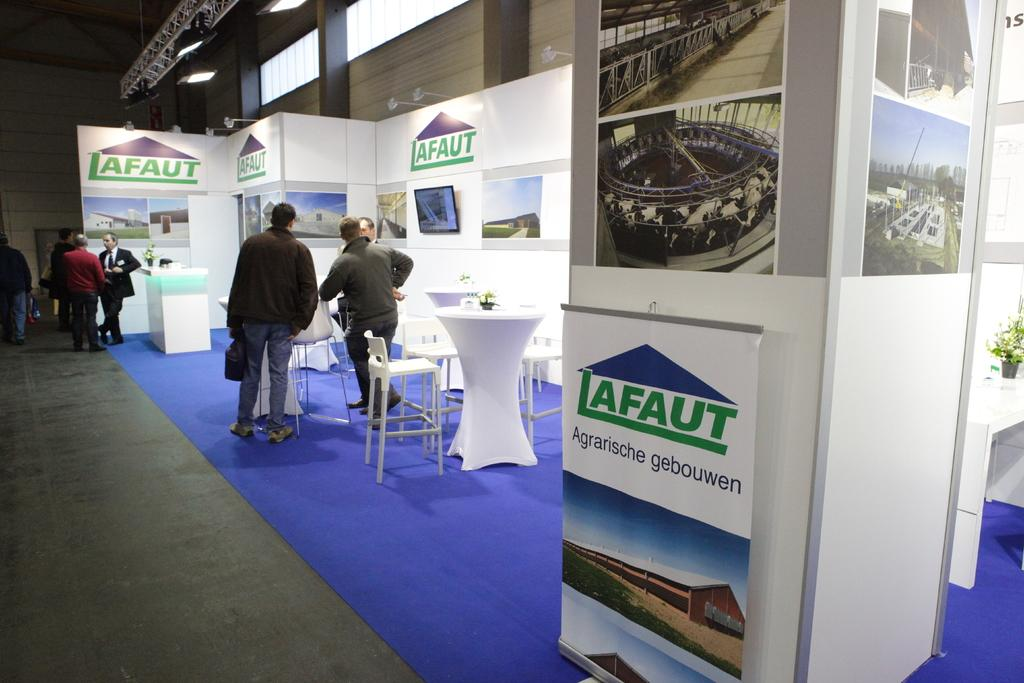<image>
Present a compact description of the photo's key features. A trade show display with blue carpet, white furniture and walls featuring multiple color images and logos with the company name. 